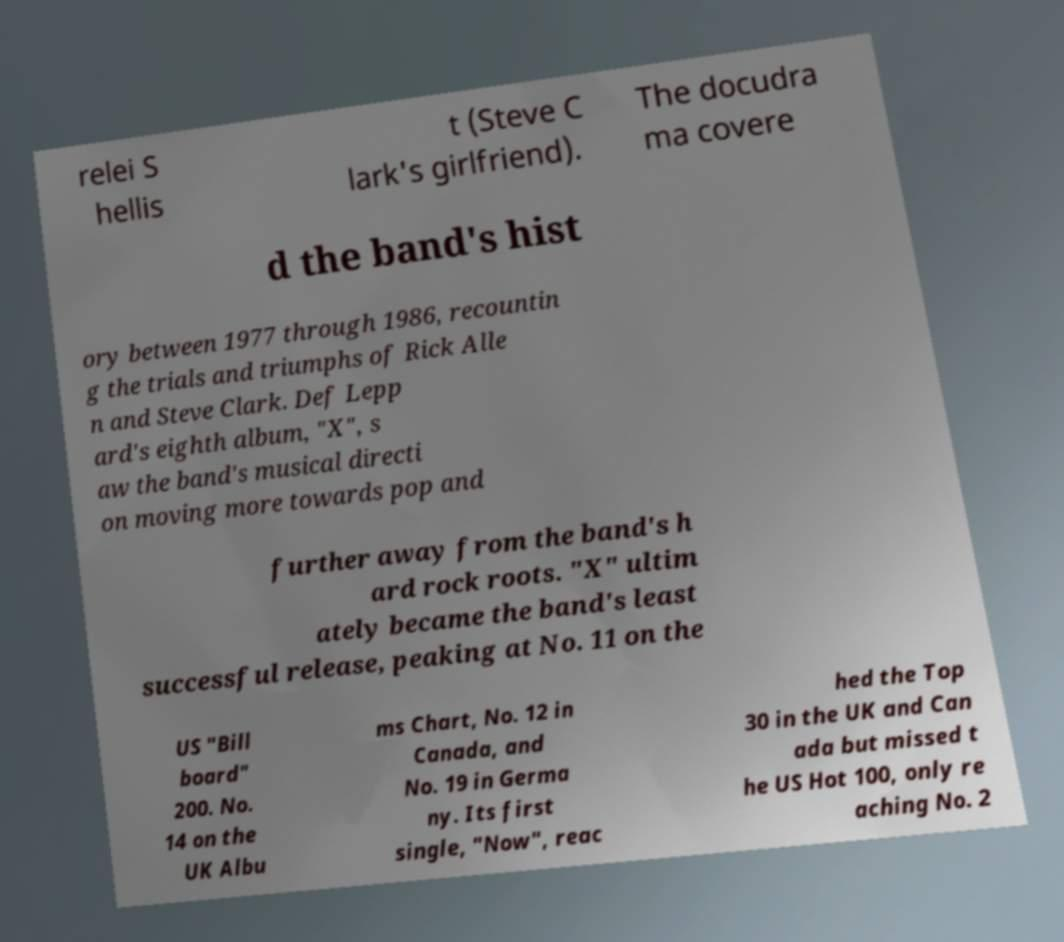Could you extract and type out the text from this image? relei S hellis t (Steve C lark's girlfriend). The docudra ma covere d the band's hist ory between 1977 through 1986, recountin g the trials and triumphs of Rick Alle n and Steve Clark. Def Lepp ard's eighth album, "X", s aw the band's musical directi on moving more towards pop and further away from the band's h ard rock roots. "X" ultim ately became the band's least successful release, peaking at No. 11 on the US "Bill board" 200. No. 14 on the UK Albu ms Chart, No. 12 in Canada, and No. 19 in Germa ny. Its first single, "Now", reac hed the Top 30 in the UK and Can ada but missed t he US Hot 100, only re aching No. 2 